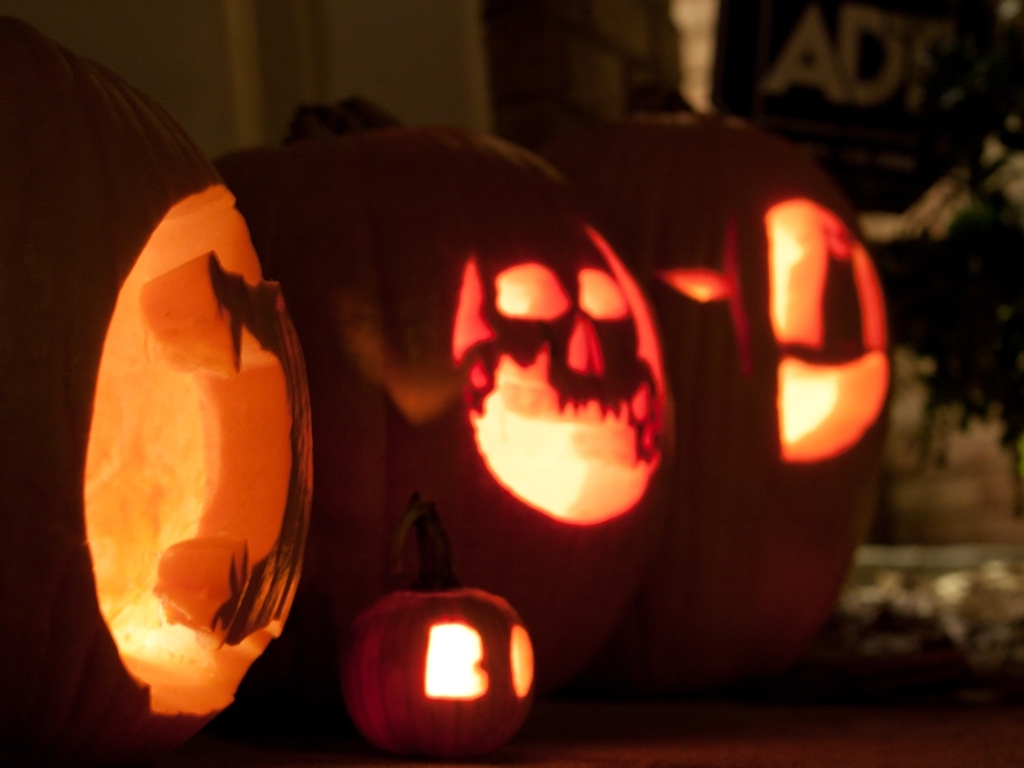How does the lighting in the image contribute to its thematic setting? The lighting plays a crucial role in enhancing the spooky theme of the image. The internal glow of the pumpkins casts eerie shadows and highlights the carved faces, creating a haunting visual synonymous with Halloween. The dim background ensures the pumpkins are the focal point, adding intensity and depth to the scene. 